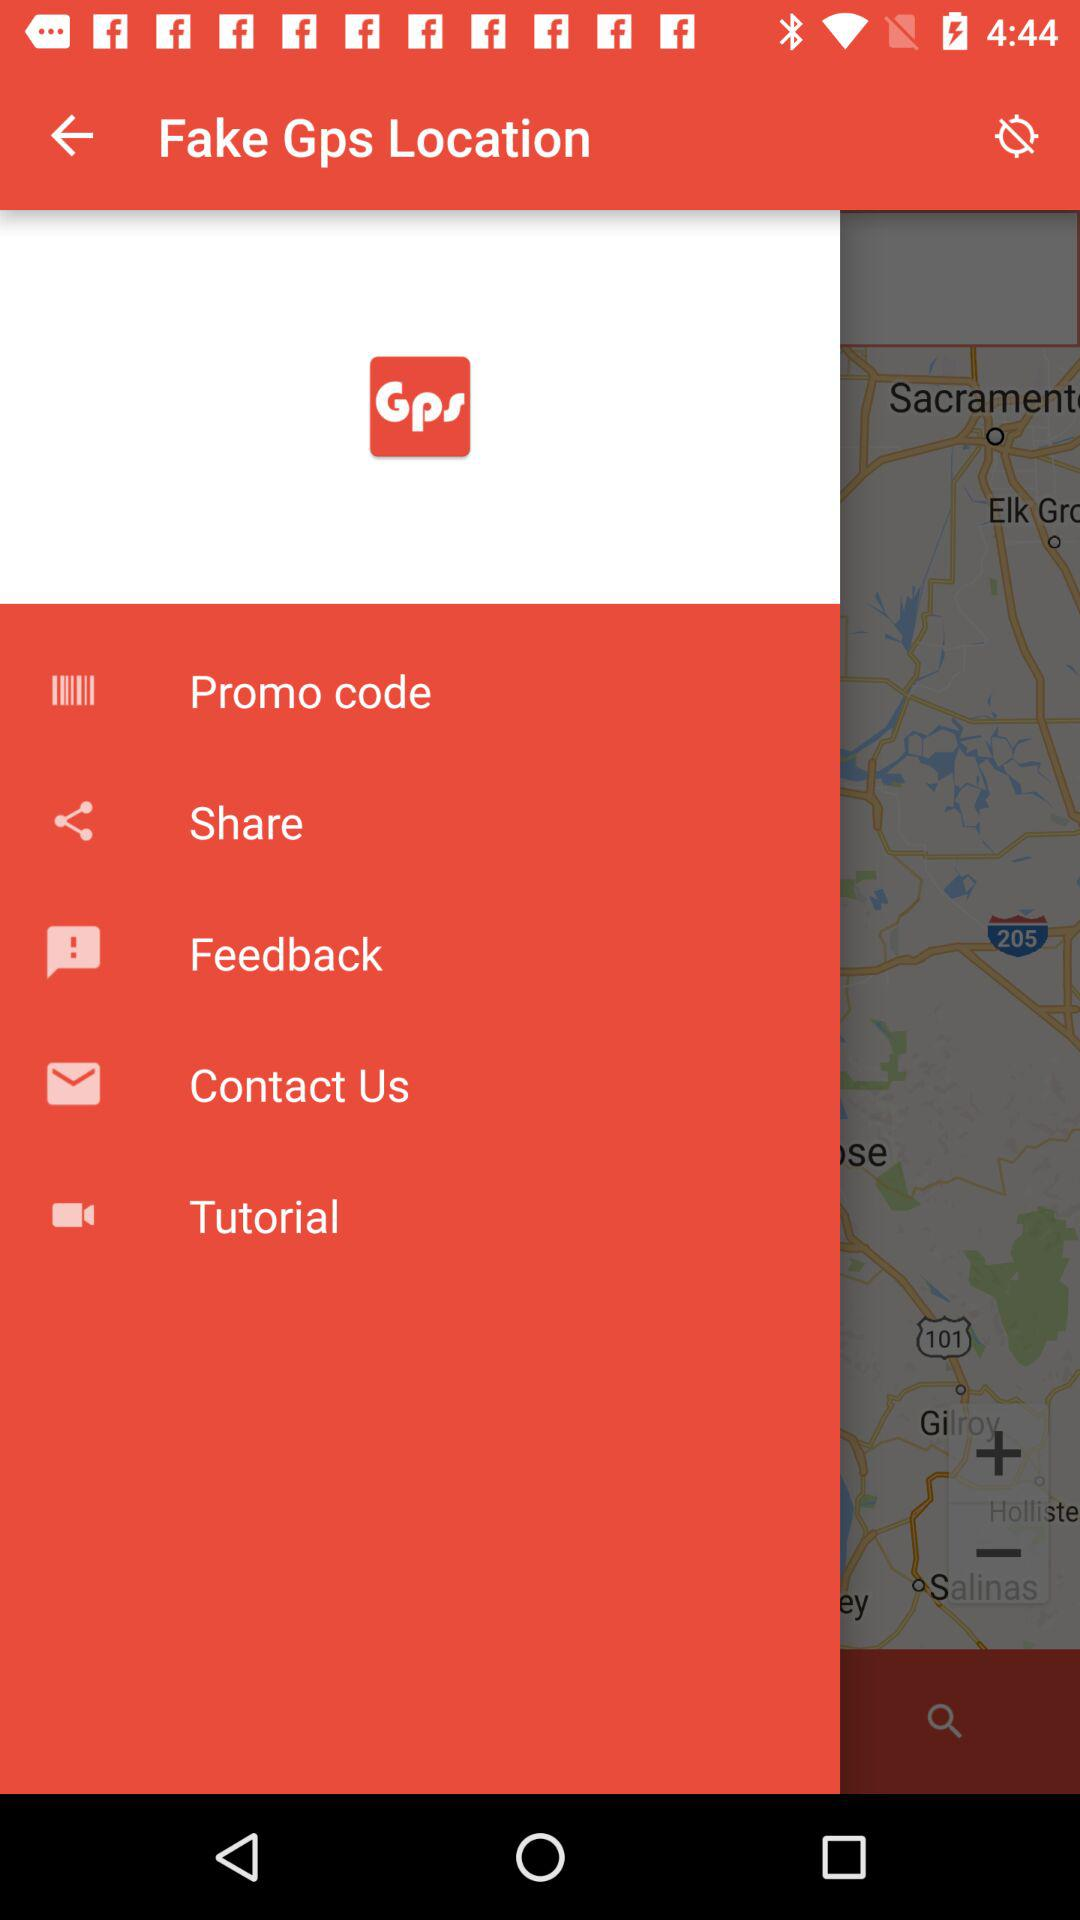What is the name of the application? The name of the application is "Fake Gps Location". 